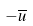Convert formula to latex. <formula><loc_0><loc_0><loc_500><loc_500>- \overline { u }</formula> 